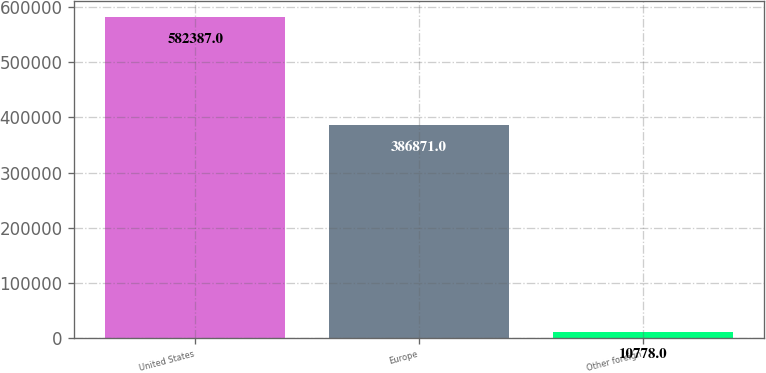Convert chart to OTSL. <chart><loc_0><loc_0><loc_500><loc_500><bar_chart><fcel>United States<fcel>Europe<fcel>Other foreign<nl><fcel>582387<fcel>386871<fcel>10778<nl></chart> 